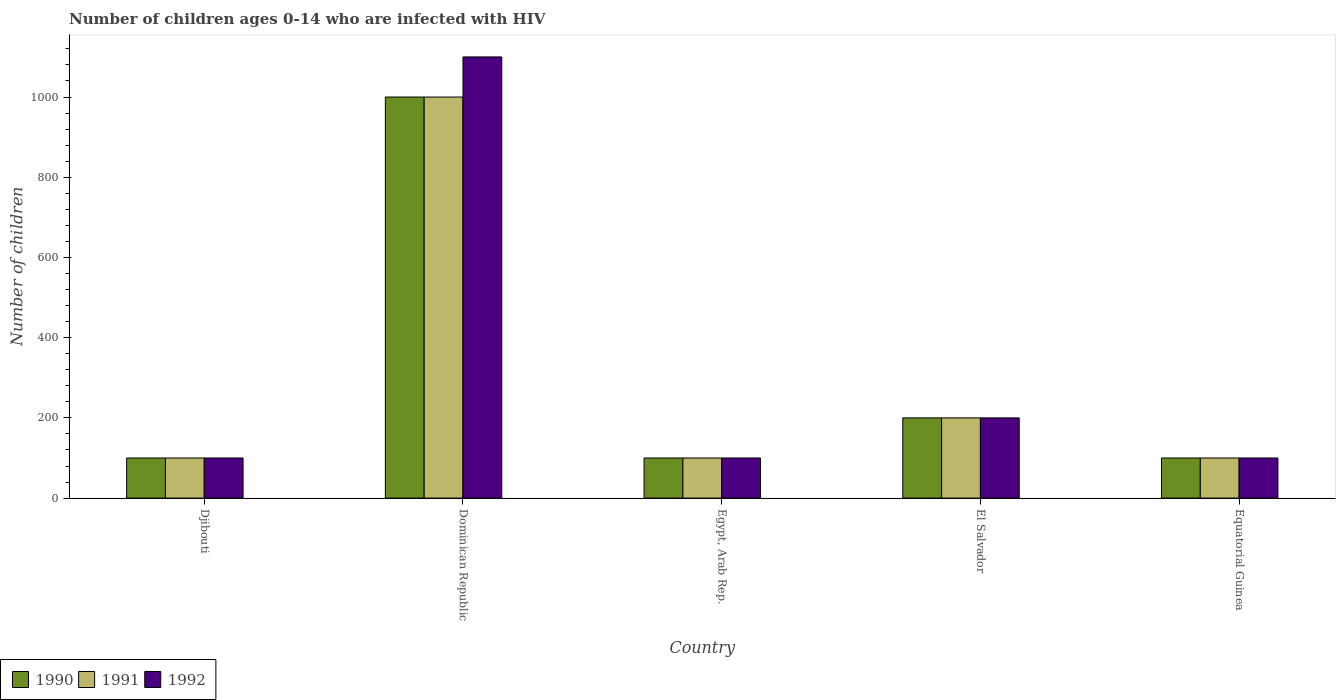How many bars are there on the 5th tick from the right?
Keep it short and to the point. 3. What is the label of the 4th group of bars from the left?
Give a very brief answer. El Salvador. In how many cases, is the number of bars for a given country not equal to the number of legend labels?
Give a very brief answer. 0. What is the number of HIV infected children in 1991 in Dominican Republic?
Make the answer very short. 1000. Across all countries, what is the maximum number of HIV infected children in 1990?
Your response must be concise. 1000. Across all countries, what is the minimum number of HIV infected children in 1992?
Your answer should be very brief. 100. In which country was the number of HIV infected children in 1990 maximum?
Give a very brief answer. Dominican Republic. In which country was the number of HIV infected children in 1991 minimum?
Offer a terse response. Djibouti. What is the total number of HIV infected children in 1990 in the graph?
Give a very brief answer. 1500. What is the difference between the number of HIV infected children in 1992 in Djibouti and that in Equatorial Guinea?
Offer a terse response. 0. What is the difference between the number of HIV infected children in 1991 in El Salvador and the number of HIV infected children in 1992 in Dominican Republic?
Provide a short and direct response. -900. What is the average number of HIV infected children in 1990 per country?
Give a very brief answer. 300. What is the difference between the number of HIV infected children of/in 1992 and number of HIV infected children of/in 1990 in Dominican Republic?
Provide a succinct answer. 100. Is the number of HIV infected children in 1990 in Djibouti less than that in Egypt, Arab Rep.?
Your answer should be very brief. No. What is the difference between the highest and the second highest number of HIV infected children in 1990?
Provide a succinct answer. 900. What is the difference between the highest and the lowest number of HIV infected children in 1992?
Make the answer very short. 1000. What does the 1st bar from the left in El Salvador represents?
Offer a terse response. 1990. Is it the case that in every country, the sum of the number of HIV infected children in 1991 and number of HIV infected children in 1992 is greater than the number of HIV infected children in 1990?
Make the answer very short. Yes. How many bars are there?
Your answer should be very brief. 15. How many countries are there in the graph?
Provide a succinct answer. 5. How are the legend labels stacked?
Make the answer very short. Horizontal. What is the title of the graph?
Your answer should be compact. Number of children ages 0-14 who are infected with HIV. Does "1979" appear as one of the legend labels in the graph?
Make the answer very short. No. What is the label or title of the X-axis?
Keep it short and to the point. Country. What is the label or title of the Y-axis?
Your response must be concise. Number of children. What is the Number of children of 1990 in Djibouti?
Your response must be concise. 100. What is the Number of children of 1992 in Djibouti?
Your answer should be compact. 100. What is the Number of children in 1990 in Dominican Republic?
Keep it short and to the point. 1000. What is the Number of children of 1991 in Dominican Republic?
Your answer should be compact. 1000. What is the Number of children in 1992 in Dominican Republic?
Provide a short and direct response. 1100. What is the Number of children in 1992 in Egypt, Arab Rep.?
Provide a short and direct response. 100. What is the Number of children of 1992 in El Salvador?
Make the answer very short. 200. What is the Number of children in 1990 in Equatorial Guinea?
Offer a terse response. 100. What is the Number of children of 1991 in Equatorial Guinea?
Your response must be concise. 100. Across all countries, what is the maximum Number of children in 1990?
Ensure brevity in your answer.  1000. Across all countries, what is the maximum Number of children of 1992?
Make the answer very short. 1100. Across all countries, what is the minimum Number of children in 1992?
Provide a short and direct response. 100. What is the total Number of children of 1990 in the graph?
Your answer should be very brief. 1500. What is the total Number of children of 1991 in the graph?
Keep it short and to the point. 1500. What is the total Number of children of 1992 in the graph?
Make the answer very short. 1600. What is the difference between the Number of children of 1990 in Djibouti and that in Dominican Republic?
Give a very brief answer. -900. What is the difference between the Number of children in 1991 in Djibouti and that in Dominican Republic?
Your answer should be very brief. -900. What is the difference between the Number of children in 1992 in Djibouti and that in Dominican Republic?
Make the answer very short. -1000. What is the difference between the Number of children of 1990 in Djibouti and that in Egypt, Arab Rep.?
Ensure brevity in your answer.  0. What is the difference between the Number of children of 1991 in Djibouti and that in Egypt, Arab Rep.?
Offer a very short reply. 0. What is the difference between the Number of children of 1990 in Djibouti and that in El Salvador?
Ensure brevity in your answer.  -100. What is the difference between the Number of children in 1991 in Djibouti and that in El Salvador?
Keep it short and to the point. -100. What is the difference between the Number of children of 1992 in Djibouti and that in El Salvador?
Your response must be concise. -100. What is the difference between the Number of children of 1991 in Djibouti and that in Equatorial Guinea?
Give a very brief answer. 0. What is the difference between the Number of children of 1990 in Dominican Republic and that in Egypt, Arab Rep.?
Your answer should be compact. 900. What is the difference between the Number of children in 1991 in Dominican Republic and that in Egypt, Arab Rep.?
Your answer should be compact. 900. What is the difference between the Number of children of 1992 in Dominican Republic and that in Egypt, Arab Rep.?
Ensure brevity in your answer.  1000. What is the difference between the Number of children of 1990 in Dominican Republic and that in El Salvador?
Provide a short and direct response. 800. What is the difference between the Number of children in 1991 in Dominican Republic and that in El Salvador?
Provide a short and direct response. 800. What is the difference between the Number of children in 1992 in Dominican Republic and that in El Salvador?
Ensure brevity in your answer.  900. What is the difference between the Number of children of 1990 in Dominican Republic and that in Equatorial Guinea?
Give a very brief answer. 900. What is the difference between the Number of children in 1991 in Dominican Republic and that in Equatorial Guinea?
Provide a short and direct response. 900. What is the difference between the Number of children in 1990 in Egypt, Arab Rep. and that in El Salvador?
Your answer should be compact. -100. What is the difference between the Number of children in 1991 in Egypt, Arab Rep. and that in El Salvador?
Provide a short and direct response. -100. What is the difference between the Number of children of 1992 in Egypt, Arab Rep. and that in El Salvador?
Provide a short and direct response. -100. What is the difference between the Number of children of 1990 in Egypt, Arab Rep. and that in Equatorial Guinea?
Offer a very short reply. 0. What is the difference between the Number of children in 1992 in Egypt, Arab Rep. and that in Equatorial Guinea?
Provide a succinct answer. 0. What is the difference between the Number of children in 1991 in El Salvador and that in Equatorial Guinea?
Ensure brevity in your answer.  100. What is the difference between the Number of children in 1992 in El Salvador and that in Equatorial Guinea?
Provide a succinct answer. 100. What is the difference between the Number of children in 1990 in Djibouti and the Number of children in 1991 in Dominican Republic?
Provide a succinct answer. -900. What is the difference between the Number of children in 1990 in Djibouti and the Number of children in 1992 in Dominican Republic?
Offer a very short reply. -1000. What is the difference between the Number of children of 1991 in Djibouti and the Number of children of 1992 in Dominican Republic?
Make the answer very short. -1000. What is the difference between the Number of children in 1990 in Djibouti and the Number of children in 1991 in Egypt, Arab Rep.?
Your answer should be compact. 0. What is the difference between the Number of children in 1990 in Djibouti and the Number of children in 1991 in El Salvador?
Your answer should be very brief. -100. What is the difference between the Number of children in 1990 in Djibouti and the Number of children in 1992 in El Salvador?
Your response must be concise. -100. What is the difference between the Number of children in 1991 in Djibouti and the Number of children in 1992 in El Salvador?
Make the answer very short. -100. What is the difference between the Number of children of 1990 in Djibouti and the Number of children of 1992 in Equatorial Guinea?
Your response must be concise. 0. What is the difference between the Number of children of 1990 in Dominican Republic and the Number of children of 1991 in Egypt, Arab Rep.?
Your answer should be compact. 900. What is the difference between the Number of children in 1990 in Dominican Republic and the Number of children in 1992 in Egypt, Arab Rep.?
Provide a short and direct response. 900. What is the difference between the Number of children of 1991 in Dominican Republic and the Number of children of 1992 in Egypt, Arab Rep.?
Offer a terse response. 900. What is the difference between the Number of children in 1990 in Dominican Republic and the Number of children in 1991 in El Salvador?
Your answer should be compact. 800. What is the difference between the Number of children of 1990 in Dominican Republic and the Number of children of 1992 in El Salvador?
Give a very brief answer. 800. What is the difference between the Number of children in 1991 in Dominican Republic and the Number of children in 1992 in El Salvador?
Provide a succinct answer. 800. What is the difference between the Number of children of 1990 in Dominican Republic and the Number of children of 1991 in Equatorial Guinea?
Ensure brevity in your answer.  900. What is the difference between the Number of children of 1990 in Dominican Republic and the Number of children of 1992 in Equatorial Guinea?
Your answer should be compact. 900. What is the difference between the Number of children in 1991 in Dominican Republic and the Number of children in 1992 in Equatorial Guinea?
Your response must be concise. 900. What is the difference between the Number of children in 1990 in Egypt, Arab Rep. and the Number of children in 1991 in El Salvador?
Ensure brevity in your answer.  -100. What is the difference between the Number of children of 1990 in Egypt, Arab Rep. and the Number of children of 1992 in El Salvador?
Your answer should be very brief. -100. What is the difference between the Number of children in 1991 in Egypt, Arab Rep. and the Number of children in 1992 in El Salvador?
Provide a succinct answer. -100. What is the difference between the Number of children in 1990 in Egypt, Arab Rep. and the Number of children in 1991 in Equatorial Guinea?
Provide a short and direct response. 0. What is the difference between the Number of children of 1990 in El Salvador and the Number of children of 1991 in Equatorial Guinea?
Ensure brevity in your answer.  100. What is the difference between the Number of children in 1990 in El Salvador and the Number of children in 1992 in Equatorial Guinea?
Make the answer very short. 100. What is the difference between the Number of children of 1991 in El Salvador and the Number of children of 1992 in Equatorial Guinea?
Your answer should be compact. 100. What is the average Number of children of 1990 per country?
Offer a very short reply. 300. What is the average Number of children of 1991 per country?
Your answer should be very brief. 300. What is the average Number of children in 1992 per country?
Ensure brevity in your answer.  320. What is the difference between the Number of children of 1990 and Number of children of 1991 in Djibouti?
Your response must be concise. 0. What is the difference between the Number of children of 1990 and Number of children of 1992 in Djibouti?
Your response must be concise. 0. What is the difference between the Number of children of 1991 and Number of children of 1992 in Djibouti?
Offer a very short reply. 0. What is the difference between the Number of children in 1990 and Number of children in 1992 in Dominican Republic?
Provide a succinct answer. -100. What is the difference between the Number of children in 1991 and Number of children in 1992 in Dominican Republic?
Make the answer very short. -100. What is the difference between the Number of children in 1990 and Number of children in 1992 in Egypt, Arab Rep.?
Provide a succinct answer. 0. What is the difference between the Number of children of 1990 and Number of children of 1991 in El Salvador?
Your response must be concise. 0. What is the difference between the Number of children in 1991 and Number of children in 1992 in El Salvador?
Your answer should be very brief. 0. What is the difference between the Number of children in 1990 and Number of children in 1992 in Equatorial Guinea?
Your answer should be compact. 0. What is the difference between the Number of children of 1991 and Number of children of 1992 in Equatorial Guinea?
Provide a short and direct response. 0. What is the ratio of the Number of children of 1992 in Djibouti to that in Dominican Republic?
Offer a terse response. 0.09. What is the ratio of the Number of children in 1991 in Djibouti to that in El Salvador?
Your answer should be very brief. 0.5. What is the ratio of the Number of children in 1992 in Djibouti to that in El Salvador?
Ensure brevity in your answer.  0.5. What is the ratio of the Number of children of 1992 in Dominican Republic to that in Egypt, Arab Rep.?
Your answer should be very brief. 11. What is the ratio of the Number of children in 1991 in Dominican Republic to that in Equatorial Guinea?
Your answer should be very brief. 10. What is the ratio of the Number of children of 1992 in Dominican Republic to that in Equatorial Guinea?
Offer a very short reply. 11. What is the ratio of the Number of children in 1990 in Egypt, Arab Rep. to that in El Salvador?
Keep it short and to the point. 0.5. What is the ratio of the Number of children of 1992 in Egypt, Arab Rep. to that in El Salvador?
Give a very brief answer. 0.5. What is the ratio of the Number of children of 1992 in Egypt, Arab Rep. to that in Equatorial Guinea?
Ensure brevity in your answer.  1. What is the ratio of the Number of children of 1990 in El Salvador to that in Equatorial Guinea?
Ensure brevity in your answer.  2. What is the difference between the highest and the second highest Number of children in 1990?
Your answer should be very brief. 800. What is the difference between the highest and the second highest Number of children in 1991?
Ensure brevity in your answer.  800. What is the difference between the highest and the second highest Number of children of 1992?
Offer a very short reply. 900. What is the difference between the highest and the lowest Number of children in 1990?
Provide a succinct answer. 900. What is the difference between the highest and the lowest Number of children in 1991?
Ensure brevity in your answer.  900. 